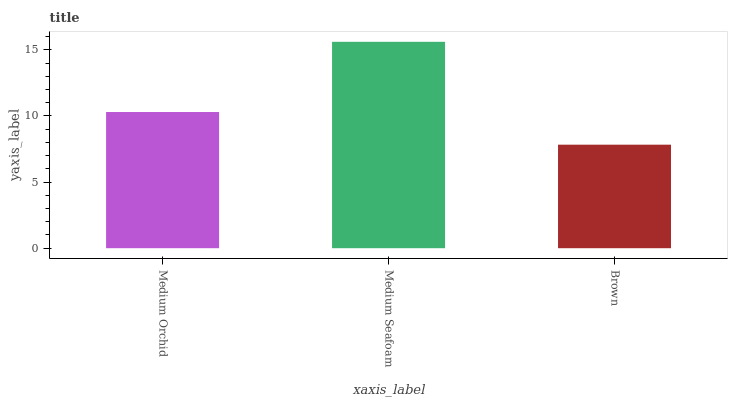Is Brown the minimum?
Answer yes or no. Yes. Is Medium Seafoam the maximum?
Answer yes or no. Yes. Is Medium Seafoam the minimum?
Answer yes or no. No. Is Brown the maximum?
Answer yes or no. No. Is Medium Seafoam greater than Brown?
Answer yes or no. Yes. Is Brown less than Medium Seafoam?
Answer yes or no. Yes. Is Brown greater than Medium Seafoam?
Answer yes or no. No. Is Medium Seafoam less than Brown?
Answer yes or no. No. Is Medium Orchid the high median?
Answer yes or no. Yes. Is Medium Orchid the low median?
Answer yes or no. Yes. Is Medium Seafoam the high median?
Answer yes or no. No. Is Brown the low median?
Answer yes or no. No. 